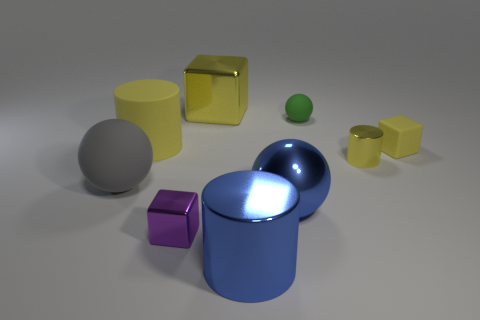How many yellow blocks must be subtracted to get 1 yellow blocks? 1 Subtract all yellow cylinders. Subtract all green balls. How many cylinders are left? 1 Add 1 tiny cyan matte things. How many objects exist? 10 Subtract all cylinders. How many objects are left? 6 Add 7 tiny brown shiny balls. How many tiny brown shiny balls exist? 7 Subtract 0 purple cylinders. How many objects are left? 9 Subtract all large red metal objects. Subtract all blue metal objects. How many objects are left? 7 Add 1 rubber blocks. How many rubber blocks are left? 2 